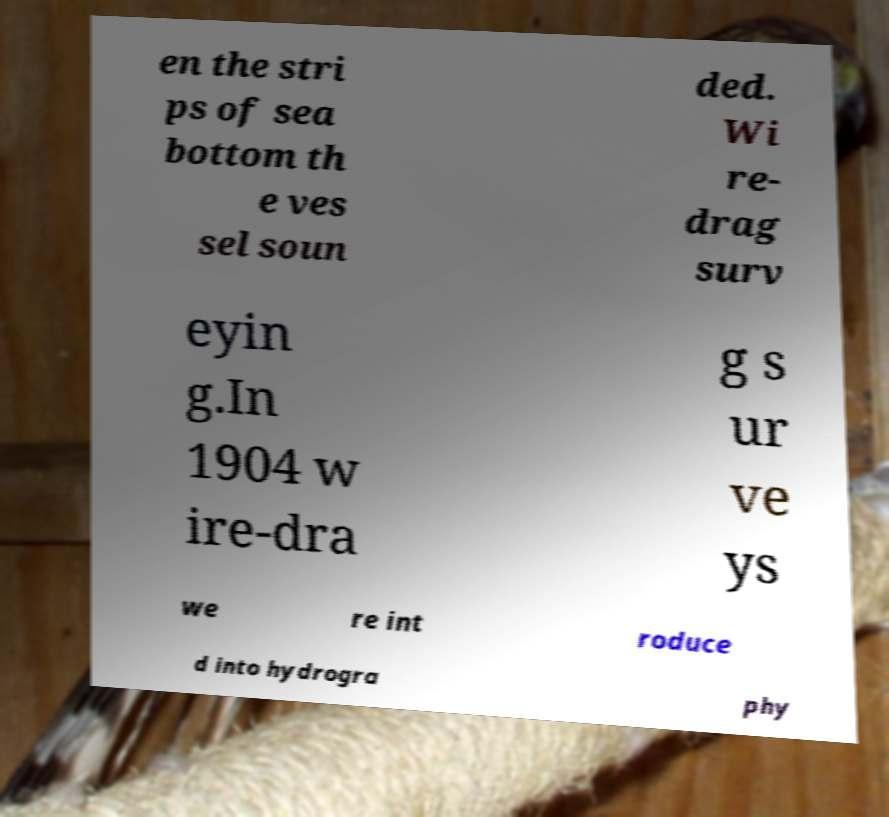Can you accurately transcribe the text from the provided image for me? en the stri ps of sea bottom th e ves sel soun ded. Wi re- drag surv eyin g.In 1904 w ire-dra g s ur ve ys we re int roduce d into hydrogra phy 